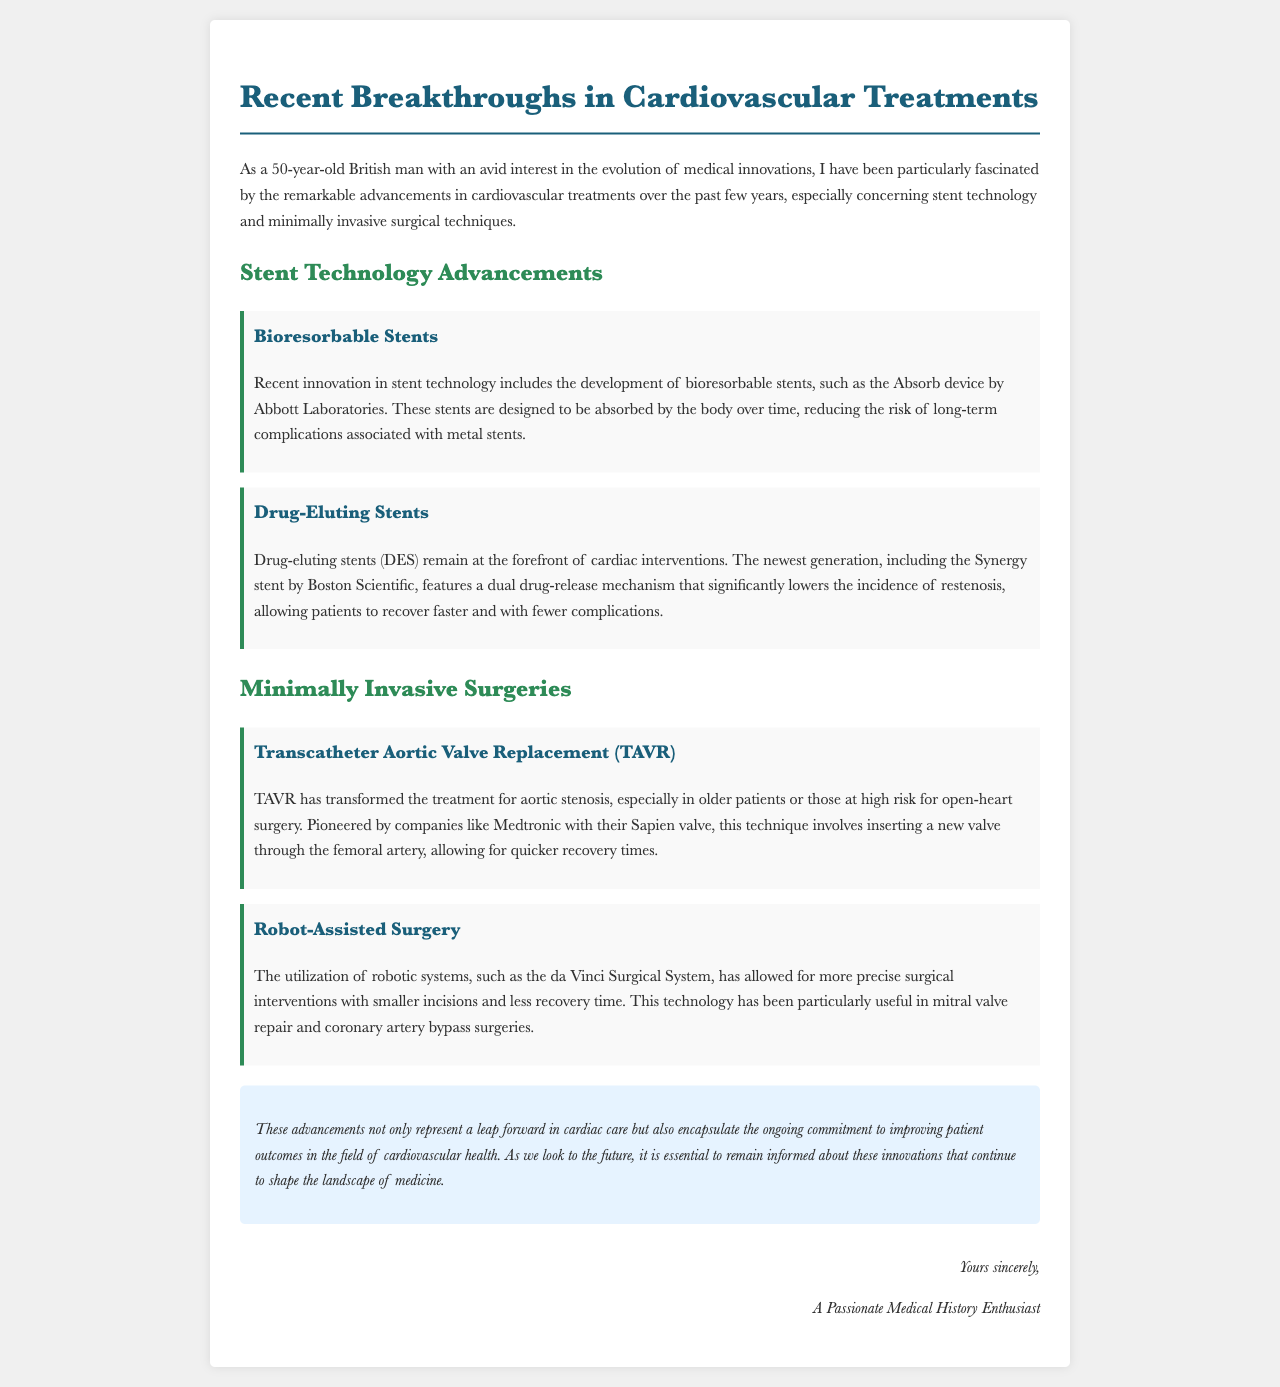What is the main focus of the letter? The letter primarily discusses recent advancements in cardiovascular treatments, particularly in stent technology and minimally invasive surgeries.
Answer: Cardiovascular treatments What type of stent is highlighted in the document as being absorbed by the body? The document mentions the bioresorbable stent, specifically the Absorb device by Abbott Laboratories, as being designed to be absorbed over time.
Answer: Bioresorbable stents Which stent features a dual drug-release mechanism? The Synergy stent by Boston Scientific is noted for its dual drug-release mechanism to reduce restenosis.
Answer: Synergy stent What surgical technique has transformed treatment for aortic stenosis? The Transcatheter Aortic Valve Replacement (TAVR) is described as having transformed aortic stenosis treatment, especially for high-risk patients.
Answer: TAVR What technology is used for more precise surgical interventions with smaller incisions? The da Vinci Surgical System is the robotic system mentioned that allows for more precise surgeries with smaller incisions.
Answer: da Vinci Surgical System Which company pioneered the TAVR procedure? Medtronic is mentioned as the company that pioneered the TAVR procedure with their Sapien valve.
Answer: Medtronic What benefit do drug-eluting stents provide for patients? Drug-eluting stents significantly reduce the incidence of restenosis, allowing for faster recovery and fewer complications.
Answer: Faster recovery What is the signature of the letter? The letter is signed off by "A Passionate Medical History Enthusiast."
Answer: A Passionate Medical History Enthusiast How does the letter conclude regarding advancements in cardiovascular health? The conclusion emphasizes the importance of remaining informed about advancements that improve patient outcomes in cardiovascular health.
Answer: Improves patient outcomes 